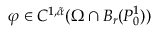Convert formula to latex. <formula><loc_0><loc_0><loc_500><loc_500>\varphi \in C ^ { 1 , \tilde { \alpha } } ( \Omega \cap B _ { r } ( P _ { 0 } ^ { 1 } ) )</formula> 